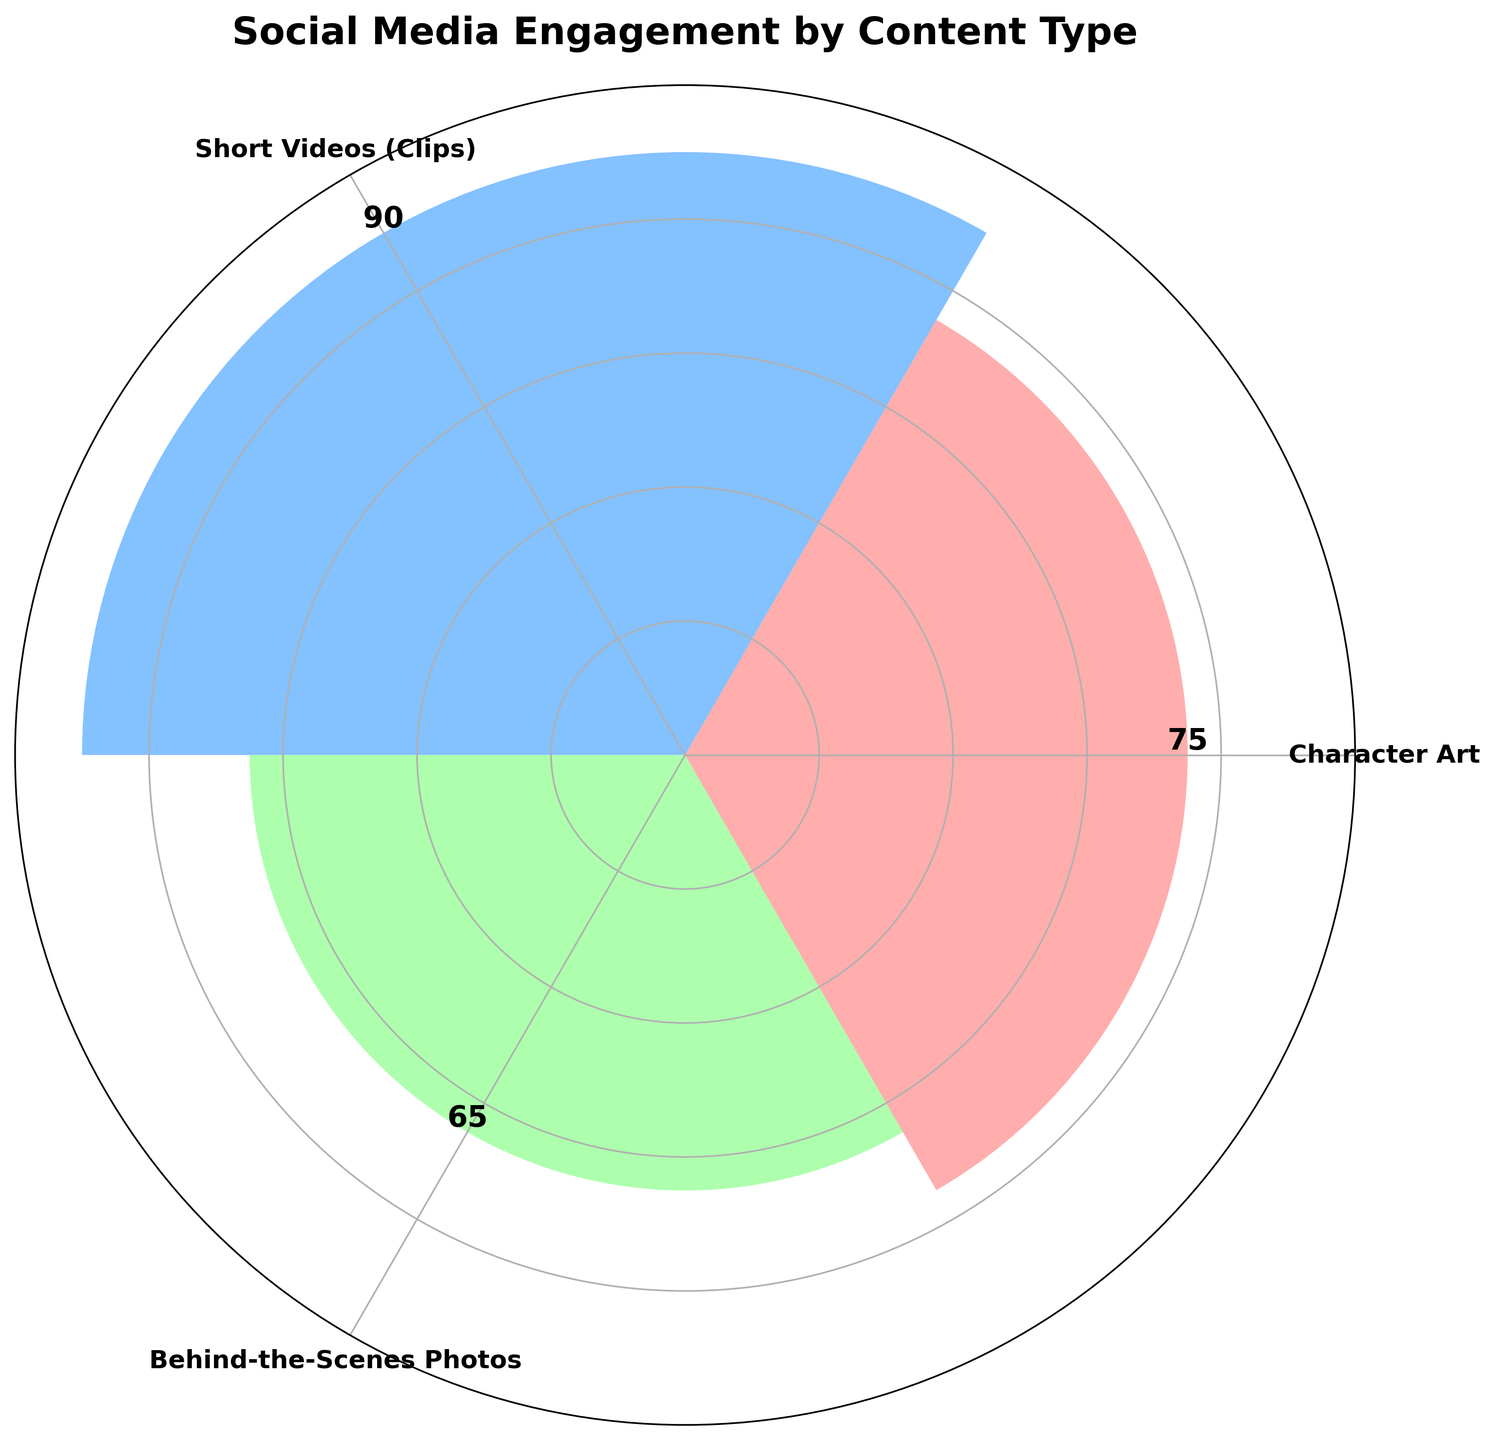Which content type has the highest engagement score? By looking at the height of the bars on the rose chart, we can see that the 'Short Videos (Clips)' bar is the tallest one.
Answer: Short Videos (Clips) What is the engagement score for behind-the-scenes photos? By reading the value text on the bar labeled 'Behind-the-Scenes Photos', we can see the engagement score is 65.
Answer: 65 How many content types are displayed on the rose chart? We can count the number of bars or labels on the chart. There are three.
Answer: 3 Which content type had the lowest engagement score among those shown? By comparing the heights of the bars, we can see that 'Behind-the-Scenes Photos' has the lowest bar.
Answer: Behind-the-Scenes Photos What is the average engagement score for the three content types represented? Add the engagement scores for the three content types (75 + 90 + 65) and divide by 3. The calculation is (75 + 90 + 65) / 3 = 230 / 3 = 76.67 (approximately).
Answer: 76.67 How does the engagement score of 'Character Art' compare to 'Short Videos (Clips)'? 'Character Art' has a shorter bar with a score of 75, whereas 'Short Videos (Clips)' has a higher bar with a score of 90. Therefore, 'Character Art' has a lower engagement score.
Answer: Lower What is the range of engagement scores among the three content types? To find the range, subtract the smallest engagement score (65) from the largest (90). The calculation is 90 - 65 = 25.
Answer: 25 What is the difference in engagement scores between 'Character Art' and 'Behind-the-Scenes Photos'? Subtract the engagement score of 'Behind-the-Scenes Photos' (65) from that of 'Character Art' (75). The calculation is 75 - 65 = 10.
Answer: 10 If you combined the engagement scores of 'Character Art' and 'Behind-the-Scenes Photos', would it be higher or lower than the engagement score of 'Short Videos (Clips)'? Add the scores for 'Character Art' (75) and 'Behind-the-Scenes Photos' (65), which equals 140, and compare it to the 'Short Videos (Clips)' score of 90. Since 140 is greater than 90, it would be higher.
Answer: Higher 